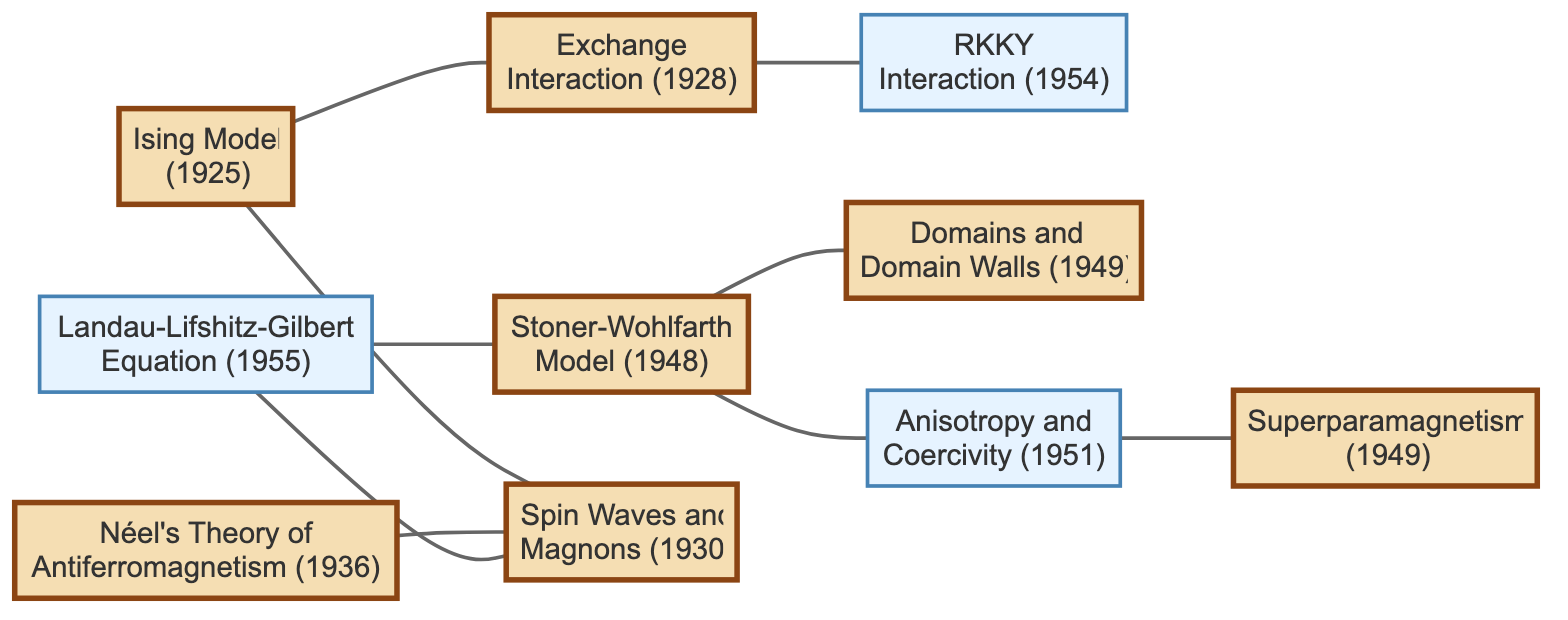What is the total number of nodes in the graph? The graph contains ten research papers represented as nodes. Counting each of the nodes listed reveals a total of ten nodes.
Answer: 10 Which paper was published in 1925? By inspecting the year associated with each node, the node with the label "Ising Model" corresponds to the year 1925.
Answer: Ising Model Who are the authors of the "Landau-Lifshitz-Gilbert Equation"? Looking at the node labeled "Landau-Lifshitz-Gilbert Equation" reveals the authors as Lev Landau, Evgeny Lifshitz, and T.L. Gilbert.
Answer: Lev Landau, Evgeny Lifshitz, T.L. Gilbert What is the relationship between the "Stoner-Wohlfarth Model" and "Domains and Domain Walls"? The graph contains an undirected edge connecting the nodes "Stoner-Wohlfarth Model" and "Domains and Domain Walls", indicating a direct relationship between these two papers.
Answer: Directly related Which two models are connected to the "Spin Waves and Magnons"? The "Spin Waves and Magnons" node is connected to two nodes: "Ising Model" and "Landau-Lifshitz-Gilbert Equation". Identifying both connections reveals these relationships.
Answer: Ising Model, Landau-Lifshitz-Gilbert Equation How many papers are cited by the "RKKY Interaction"? The "RKKY Interaction" node has one outgoing edge connecting to the "Exchange Interaction" node, indicating that one paper cites it.
Answer: 1 Which paper has both "Exchange Interaction" and "Anisotropy and Coercivity" as its connections? The "Stoner-Wohlfarth Model" node connects to the "Exchange Interaction" and also connects to "Anisotropy and Coercivity". Thus, it is the only paper connected to both.
Answer: Stoner-Wohlfarth Model What is the earliest paper in this citation network? The year corresponding to each node is examined, and "Ising Model" with the year 1925 is the earliest paper among the nodes present in the graph.
Answer: Ising Model 